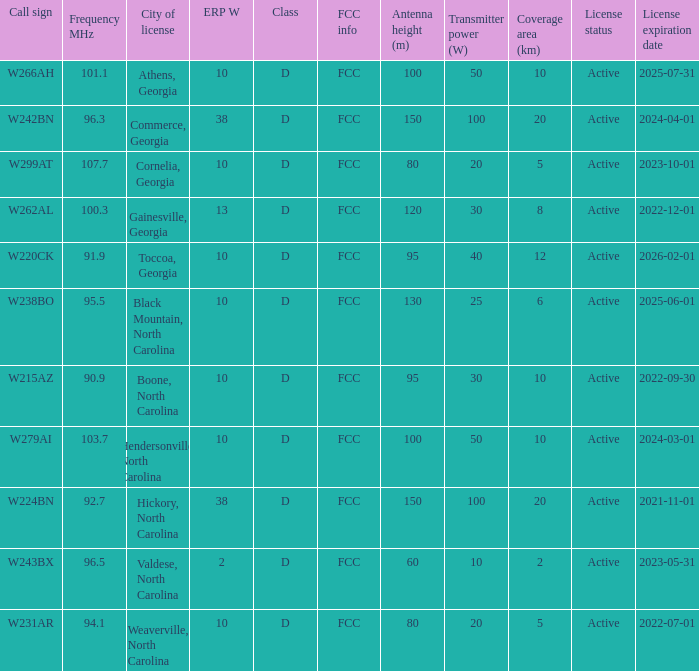What city has larger than 94.1 as a frequency? Athens, Georgia, Commerce, Georgia, Cornelia, Georgia, Gainesville, Georgia, Black Mountain, North Carolina, Hendersonville, North Carolina, Valdese, North Carolina. 